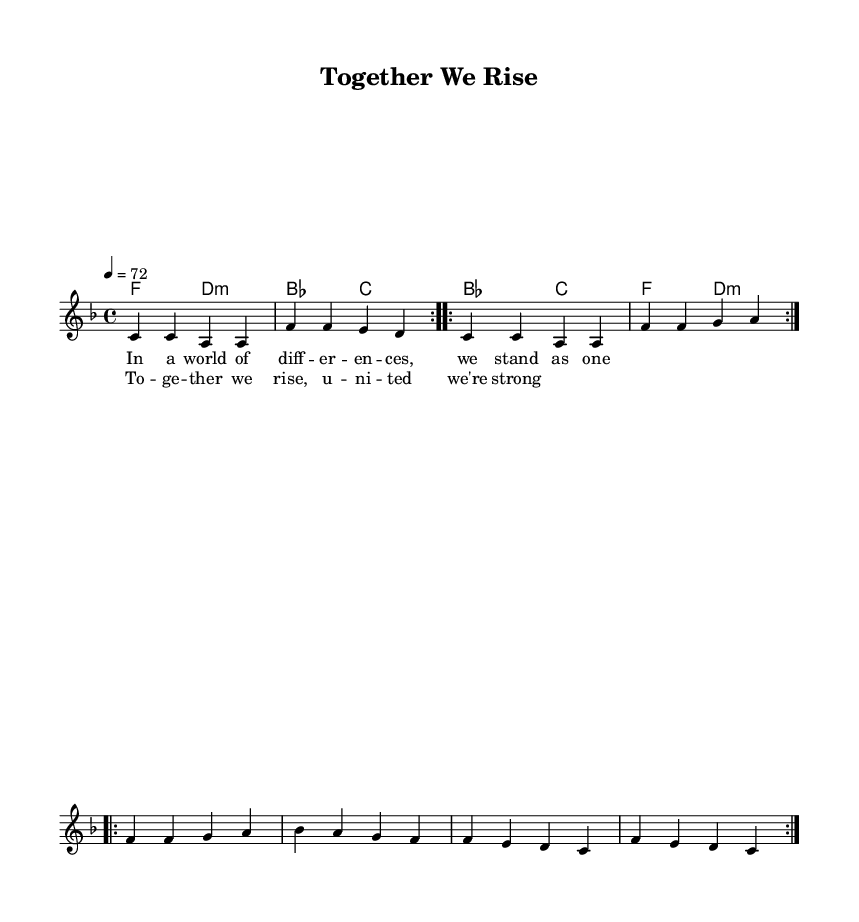What is the key signature of this music? The key signature is F major, which has one flat (B flat) indicated at the beginning of the staff.
Answer: F major What is the time signature of this music? The time signature is indicated as 4/4, meaning there are four beats in each measure and the quarter note gets one beat.
Answer: 4/4 What is the tempo of this piece? The tempo marking shows 4 equals 72, indicating the piece should be played at a speed of 72 beats per minute.
Answer: 72 How many repetitions of the melody are indicated in the score? The score shows "repeat volta 2," indicating that each section of the melody should be played twice, leading to a total of two repetitions.
Answer: 2 What is the main theme of the lyrics? The lyrics express themes of unity and strength in diversity, emphasizing togetherness in the face of differences.
Answer: Unity What chord does the melody start on? The melody begins with the note C in the first measure; thus, the corresponding chord played alongside is F major.
Answer: F What is the format of the overall structure in this music? The song structure includes verses that depict a message of togetherness followed by a chorus that reinforces the main theme of unity.
Answer: Verse and Chorus 